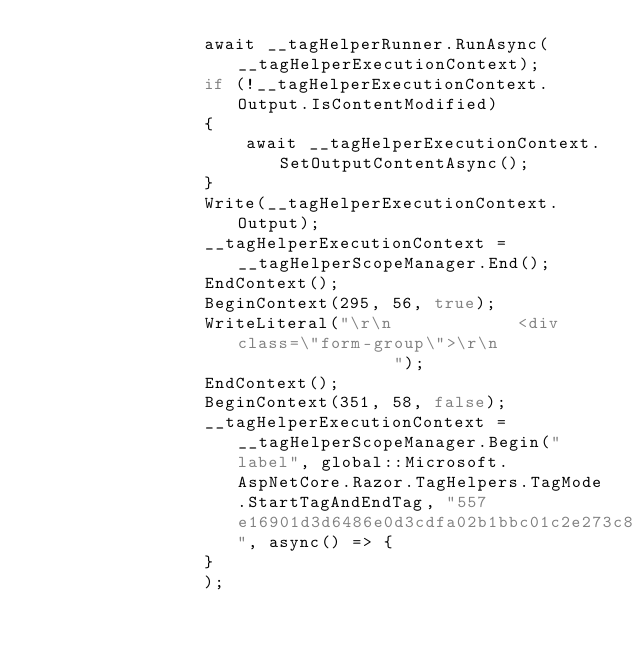<code> <loc_0><loc_0><loc_500><loc_500><_C#_>                await __tagHelperRunner.RunAsync(__tagHelperExecutionContext);
                if (!__tagHelperExecutionContext.Output.IsContentModified)
                {
                    await __tagHelperExecutionContext.SetOutputContentAsync();
                }
                Write(__tagHelperExecutionContext.Output);
                __tagHelperExecutionContext = __tagHelperScopeManager.End();
                EndContext();
                BeginContext(295, 56, true);
                WriteLiteral("\r\n            <div class=\"form-group\">\r\n                ");
                EndContext();
                BeginContext(351, 58, false);
                __tagHelperExecutionContext = __tagHelperScopeManager.Begin("label", global::Microsoft.AspNetCore.Razor.TagHelpers.TagMode.StartTagAndEndTag, "557e16901d3d6486e0d3cdfa02b1bbc01c2e273c8461", async() => {
                }
                );</code> 